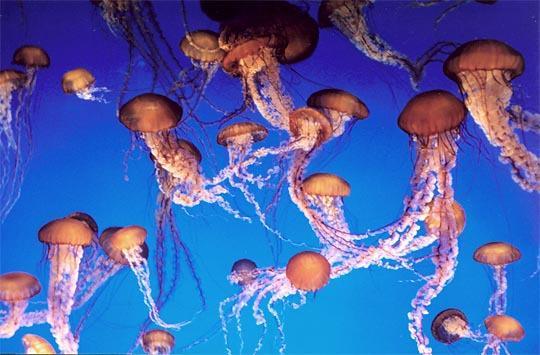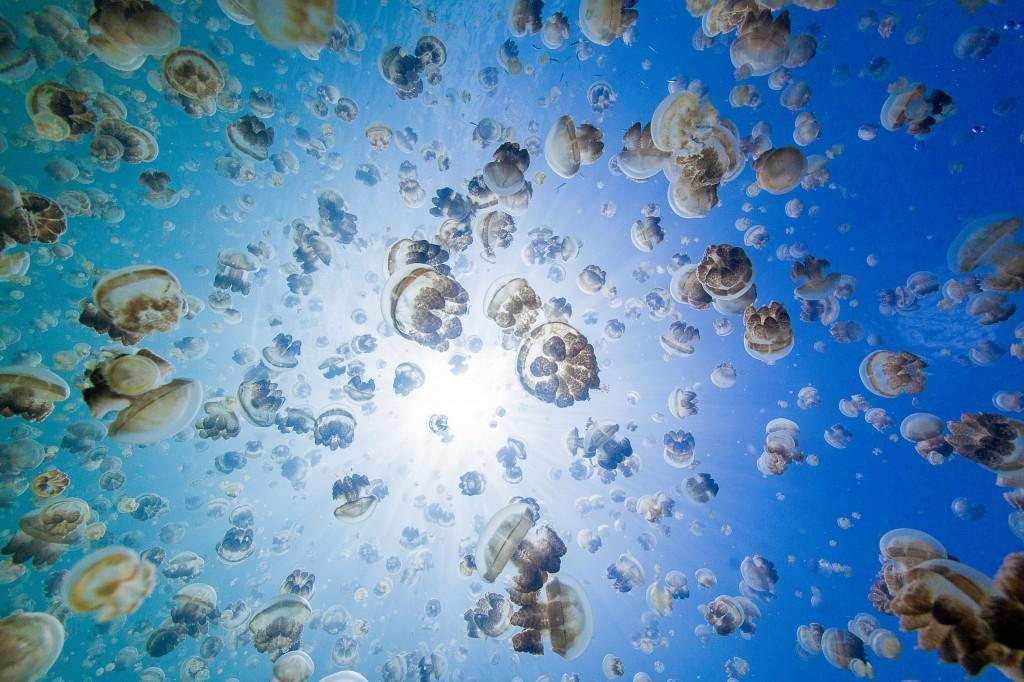The first image is the image on the left, the second image is the image on the right. Analyze the images presented: Is the assertion "There are pink jellyfish in the image on the left." valid? Answer yes or no. Yes. The first image is the image on the left, the second image is the image on the right. For the images displayed, is the sentence "In one of the images, there are warm colored jellyfish" factually correct? Answer yes or no. Yes. 